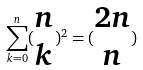<formula> <loc_0><loc_0><loc_500><loc_500>\sum _ { k = 0 } ^ { n } ( \begin{matrix} n \\ k \end{matrix} ) ^ { 2 } = ( \begin{matrix} 2 n \\ n \end{matrix} )</formula> 